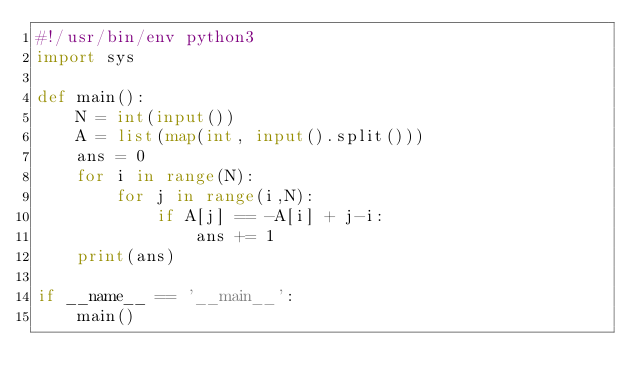Convert code to text. <code><loc_0><loc_0><loc_500><loc_500><_Python_>#!/usr/bin/env python3
import sys

def main():
    N = int(input())
    A = list(map(int, input().split()))
    ans = 0
    for i in range(N):
        for j in range(i,N):
            if A[j] == -A[i] + j-i:
                ans += 1
    print(ans)

if __name__ == '__main__':
    main()
</code> 